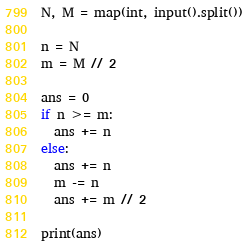<code> <loc_0><loc_0><loc_500><loc_500><_Python_>N, M = map(int, input().split())

n = N
m = M // 2

ans = 0
if n >= m:
  ans += n
else:
  ans += n
  m -= n
  ans += m // 2
  
print(ans)</code> 